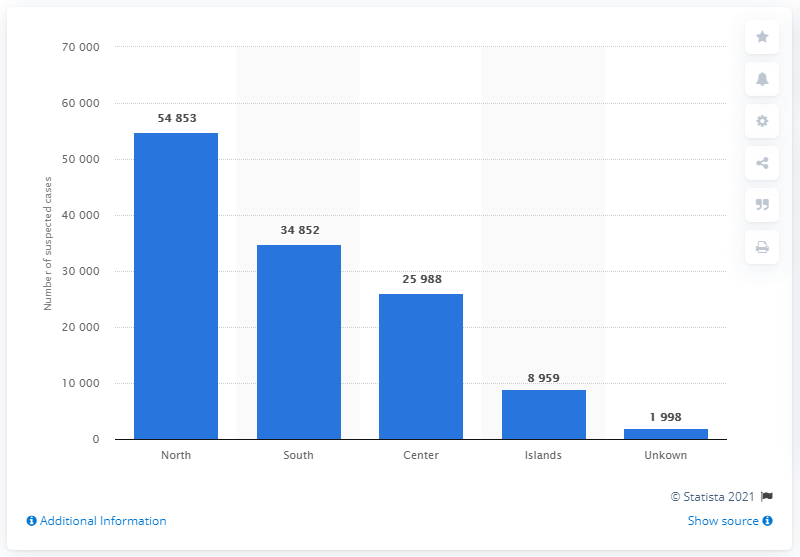Highlight a few significant elements in this photo. In 2019, there were 54,853 suspected operations in the North of Italy. There were 34,852 cases of suspected money laundering registered in the Southern regions in 2019. 